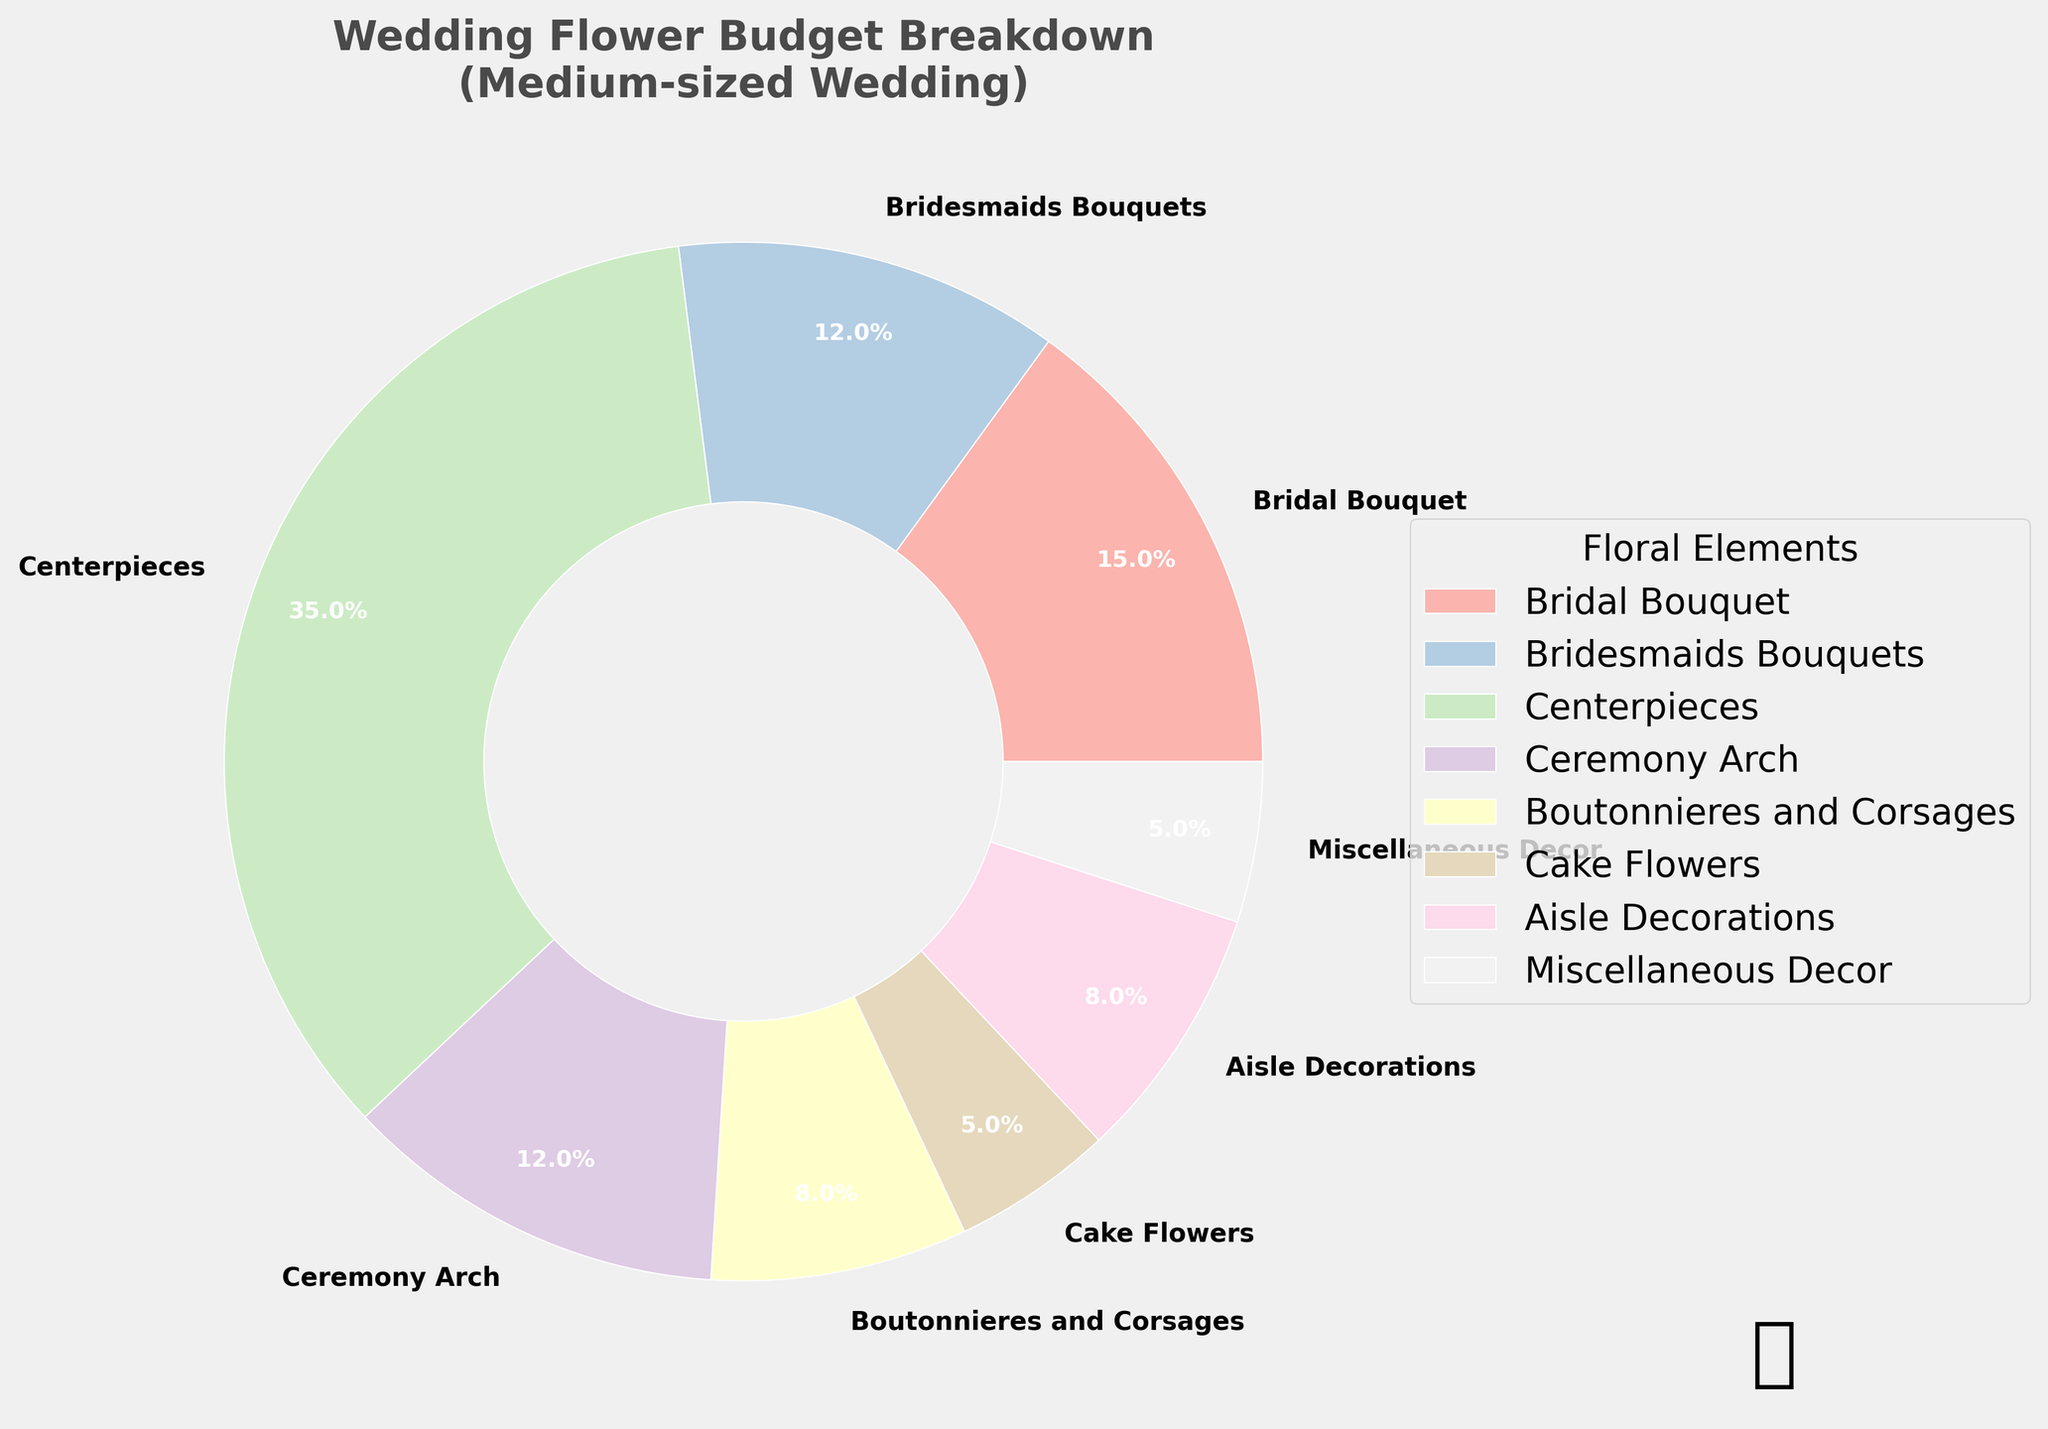What percentage of the budget is allocated to Aisle Decorations? To find the percentage for Aisle Decorations, look at the part of the pie chart labeled 'Aisle Decorations'. The segment shows 8%.
Answer: 8% How much more of the budget is spent on Centerpieces compared to Ceremony Arch? Find the percentages for both elements in the chart. Centerpieces are 35% and Ceremony Arch is 12%. Then calculate the difference: 35% - 12% = 23%.
Answer: 23% What is the combined budget percentage for Boutonnieres and Corsages, and Cake Flowers? Locate the percentages for Boutonnieres and Corsages (8%) and Cake Flowers (5%) in the chart. Then sum them up: 8% + 5% = 13%.
Answer: 13% Which floral element has the largest budget allocation? Find the largest segment in the pie chart. Centerpieces have the highest percentage at 35%.
Answer: Centerpieces Between Bridesmaids Bouquets and Miscellaneous Decor, which one has a higher budget allocation and by how much? Find the percentages for Bridesmaids Bouquets (12%) and Miscellaneous Decor (5%). Calculate the difference: 12% - 5% = 7%.
Answer: Bridesmaids Bouquets by 7% What floral elements have an equal budget allocation? Look for segments in the pie chart with identical percentages. Cake Flowers and Miscellaneous Decor both have a budget allocation of 5%.
Answer: Cake Flowers and Miscellaneous Decor What percentage of the budget is devoted to non-ceremony elements (all other elements excluding Ceremony Arch and Aisle Decorations)? First, find the percentages for Ceremony Arch (12%) and Aisle Decorations (8%). Then sum them: 12% + 8% = 20%. Subtract from 100%: 100% - 20% = 80%.
Answer: 80% How does the budget for the Bridal Bouquet compare to that for Boutonnieres and Corsages? The Bridal Bouquet is 15% and Boutonnieres and Corsages are 8%. The Bridal Bouquet is higher by 15% - 8% = 7%.
Answer: 7% Which color represents the Bridal Bouquet in the pie chart? Identify the color of the segment labeled 'Bridal Bouquet'. The exact color can be determined visually in the chart.
Answer: [Provide accurate color based on visual inspection of the chart] If we were to redistribute 5% from Centerpieces to Aisle Decorations, what would be the new percentage for each? Centerpieces are initially 35% and Aisle Decorations 8%. Redistributing 5%: Centerpieces = 35% - 5% = 30%; Aisle Decorations = 8% + 5% = 13%.
Answer: Centerpieces: 30%, Aisle Decorations: 13% 